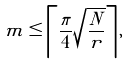Convert formula to latex. <formula><loc_0><loc_0><loc_500><loc_500>m \leq \left \lceil \frac { \pi } { 4 } \sqrt { \frac { N } { r } } \right \rceil ,</formula> 